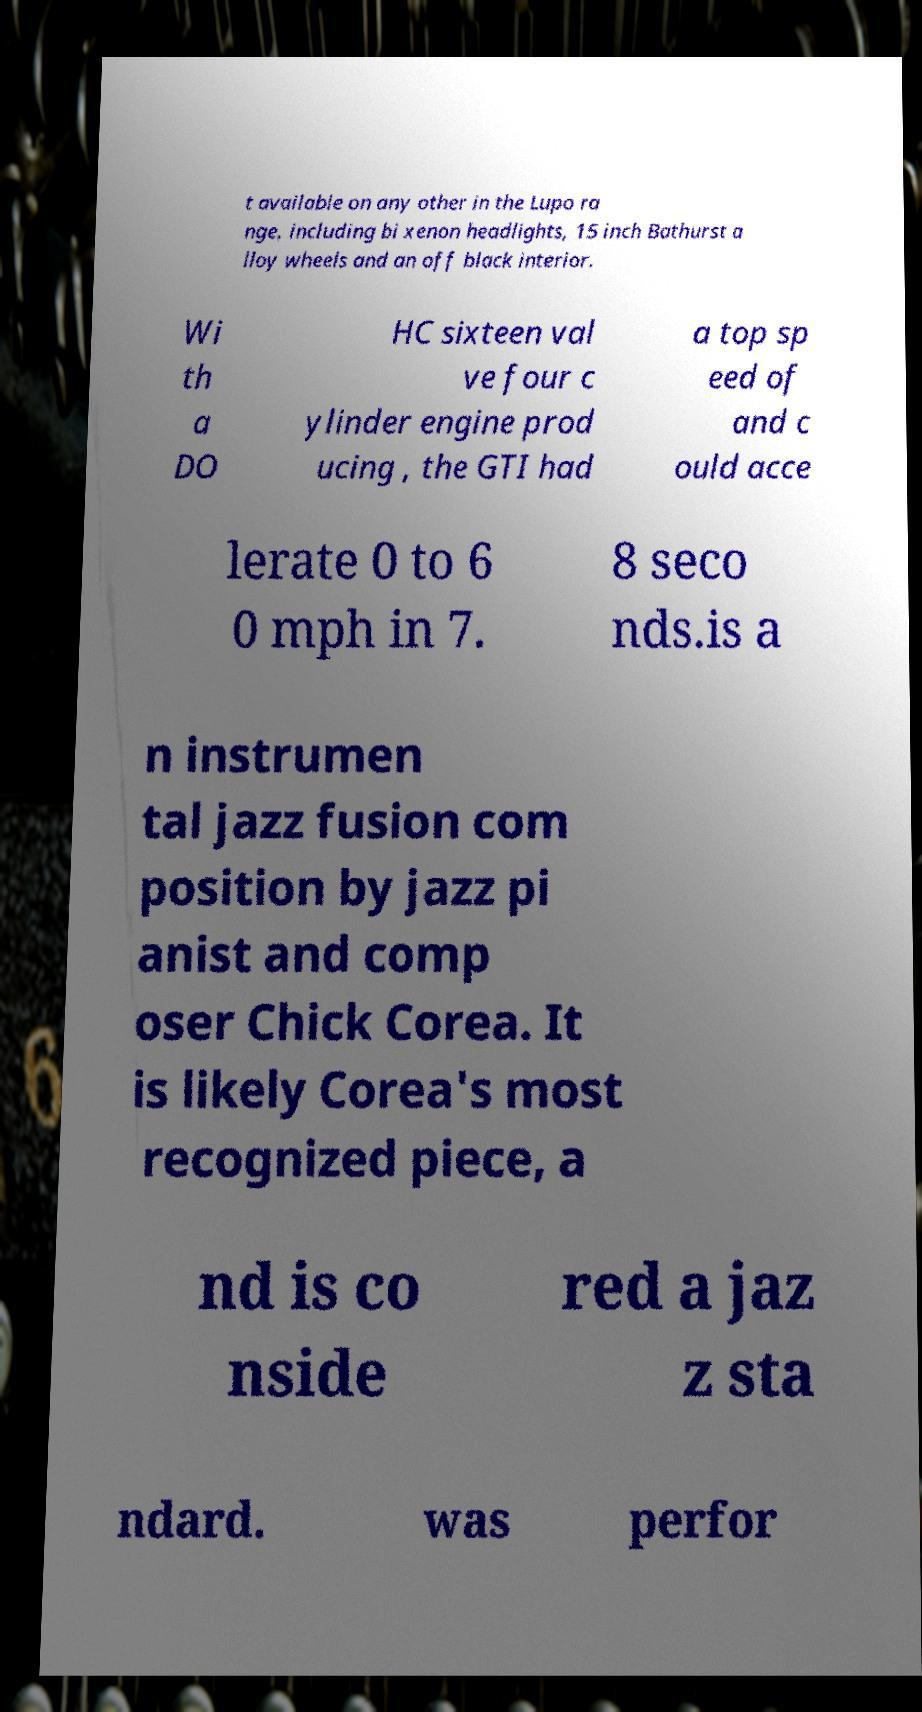Could you extract and type out the text from this image? t available on any other in the Lupo ra nge, including bi xenon headlights, 15 inch Bathurst a lloy wheels and an off black interior. Wi th a DO HC sixteen val ve four c ylinder engine prod ucing , the GTI had a top sp eed of and c ould acce lerate 0 to 6 0 mph in 7. 8 seco nds.is a n instrumen tal jazz fusion com position by jazz pi anist and comp oser Chick Corea. It is likely Corea's most recognized piece, a nd is co nside red a jaz z sta ndard. was perfor 